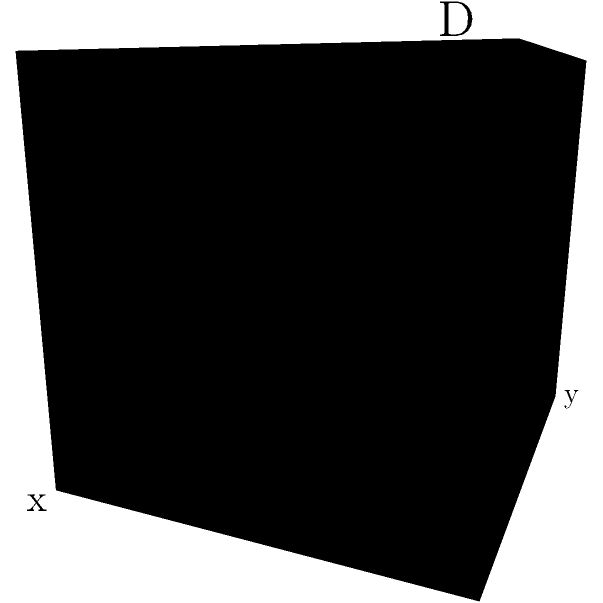A climbing plant is growing on a vertical trellis represented by a 3D coordinate system. The plant's growth is tracked at four points: A(0,0,0), B(0.2,0.3,0.4), C(0.5,0.6,0.7), and D(0.8,0.9,1). What is the total vertical distance the plant has grown from point A to point D? To find the total vertical distance the plant has grown from point A to point D, we need to focus on the z-coordinate, which represents the vertical dimension in this 3D system. Let's follow these steps:

1. Identify the z-coordinates of points A and D:
   - Point A: (0,0,0), so z_A = 0
   - Point D: (0.8,0.9,1), so z_D = 1

2. Calculate the difference between the z-coordinates:
   Vertical distance = z_D - z_A
                     = 1 - 0
                     = 1

3. Interpret the result:
   The plant has grown a total vertical distance of 1 unit from point A to point D.

Note: In this coordinate system, 1 unit could represent any real-world measurement (e.g., 1 meter, 1 foot, etc.) depending on the scale chosen for the trellis representation.
Answer: 1 unit 